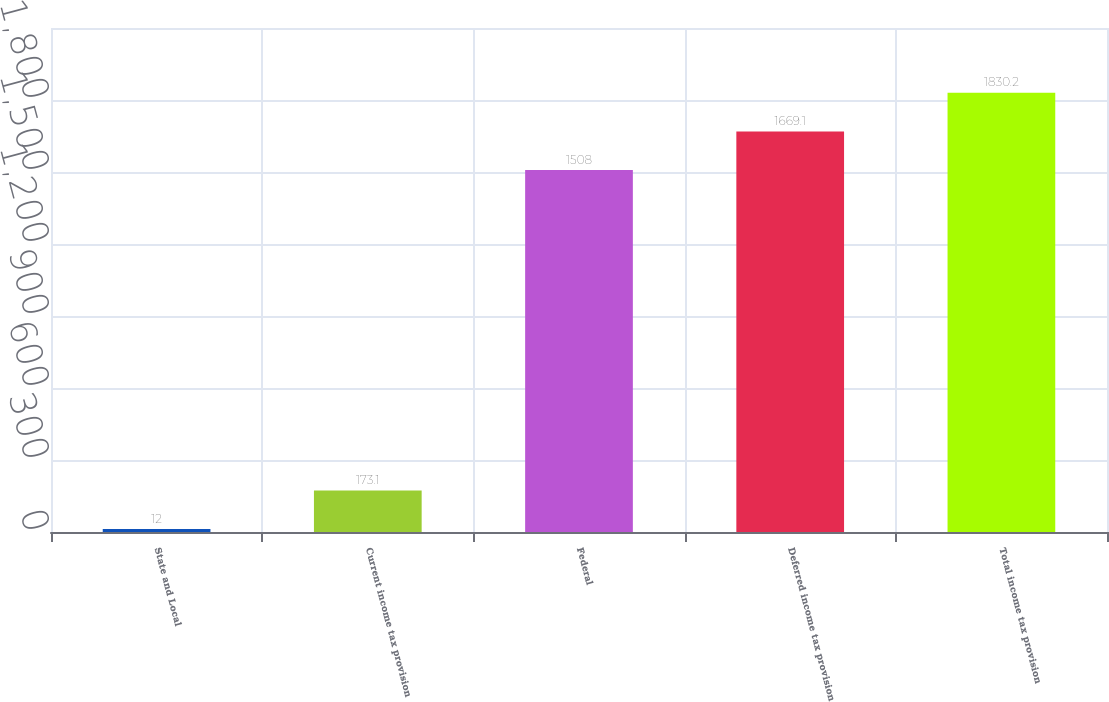<chart> <loc_0><loc_0><loc_500><loc_500><bar_chart><fcel>State and Local<fcel>Current income tax provision<fcel>Federal<fcel>Deferred income tax provision<fcel>Total income tax provision<nl><fcel>12<fcel>173.1<fcel>1508<fcel>1669.1<fcel>1830.2<nl></chart> 